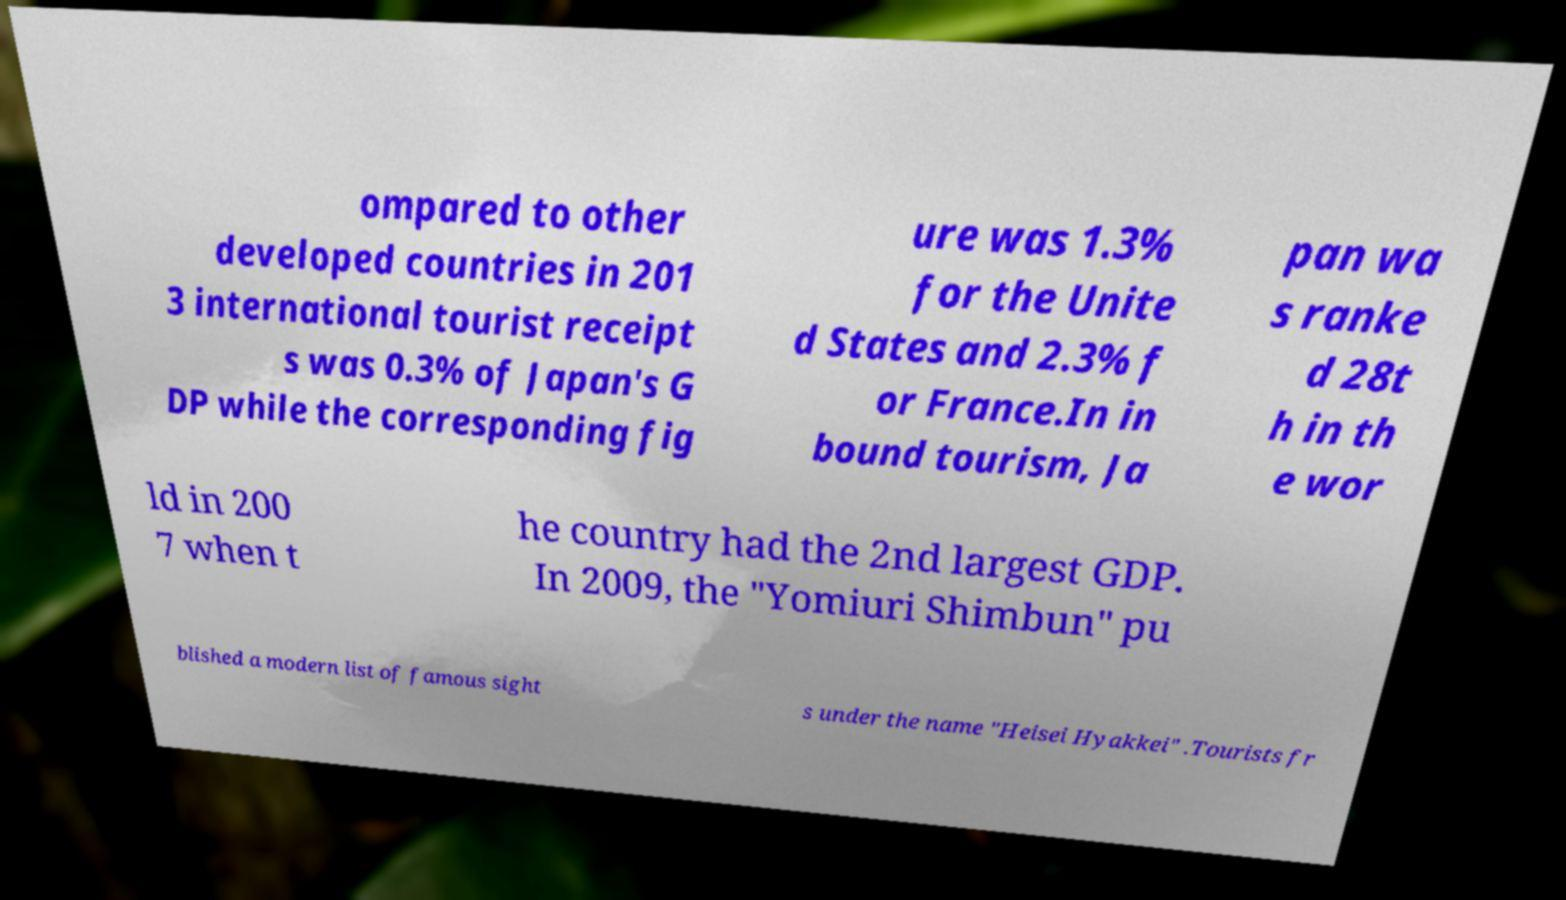Can you accurately transcribe the text from the provided image for me? ompared to other developed countries in 201 3 international tourist receipt s was 0.3% of Japan's G DP while the corresponding fig ure was 1.3% for the Unite d States and 2.3% f or France.In in bound tourism, Ja pan wa s ranke d 28t h in th e wor ld in 200 7 when t he country had the 2nd largest GDP. In 2009, the "Yomiuri Shimbun" pu blished a modern list of famous sight s under the name "Heisei Hyakkei" .Tourists fr 